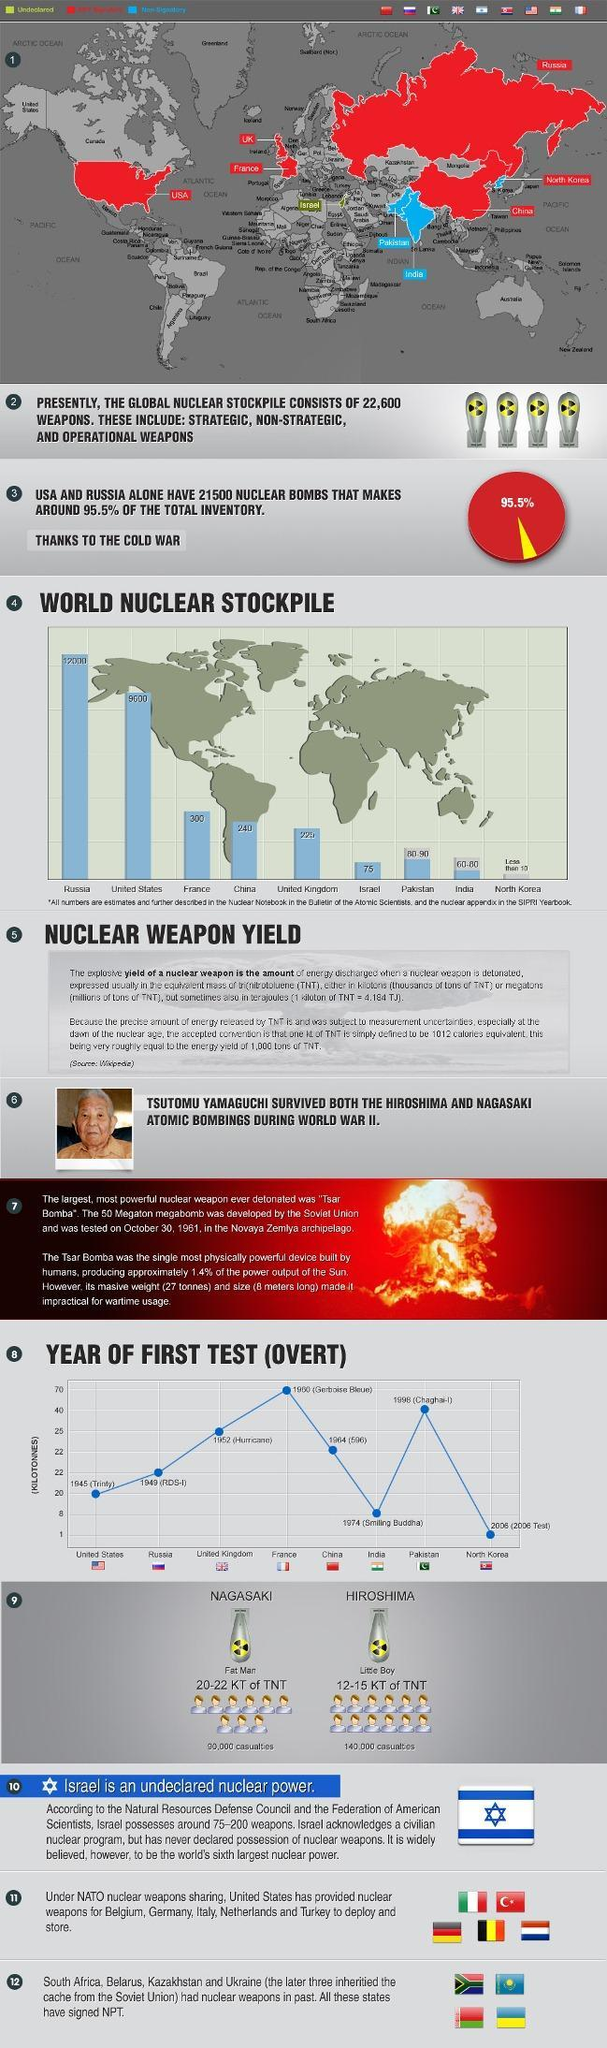Which was the first nuclear test of US and when was it conducted?
Answer the question with a short phrase. Trinity, 1945 How many casualties were there in Hiroshima? 140,000 Which type of atom bomb was used in Hiroshima? Little boy Who holds more nuclear weapons, India or Pakistan? Pakistan Which was UK's first nuclear test and when was it conducted? Hurricane, 1952 How many nuclear weapons does Russia have? 12,000 Which country holds undeclared nuclear weapons? Israel How many kilo tons of TNT was little boy? 12-15 How many nuclear weapons does US hold? 9000 Which country is the world's 6th largest nuclear power? Israel What was the length of Tsar Bomba? 8 metres What was the weight of Tsar Bomba? 27 tonnes How many kilotons of TNT was fat man? 20-22 What is the total stock of nuclear weapons in the world? 22,600 How many casualties were there in Nagasaki? 90,000 Which type of atom bomb was used in Nagasaki? Fat man Which two features of Tsar Bomba, made it difficult to be used for war? Massive weight, size Who has more nuclear weapons, the US or Russia? Russia Which was India's first nuclear test and when was it conducted? Smiling Buddha, 1974 Who holds more nuclear weapons, China or India? China Which were the two types of bombs produced? Fat man, little boy 